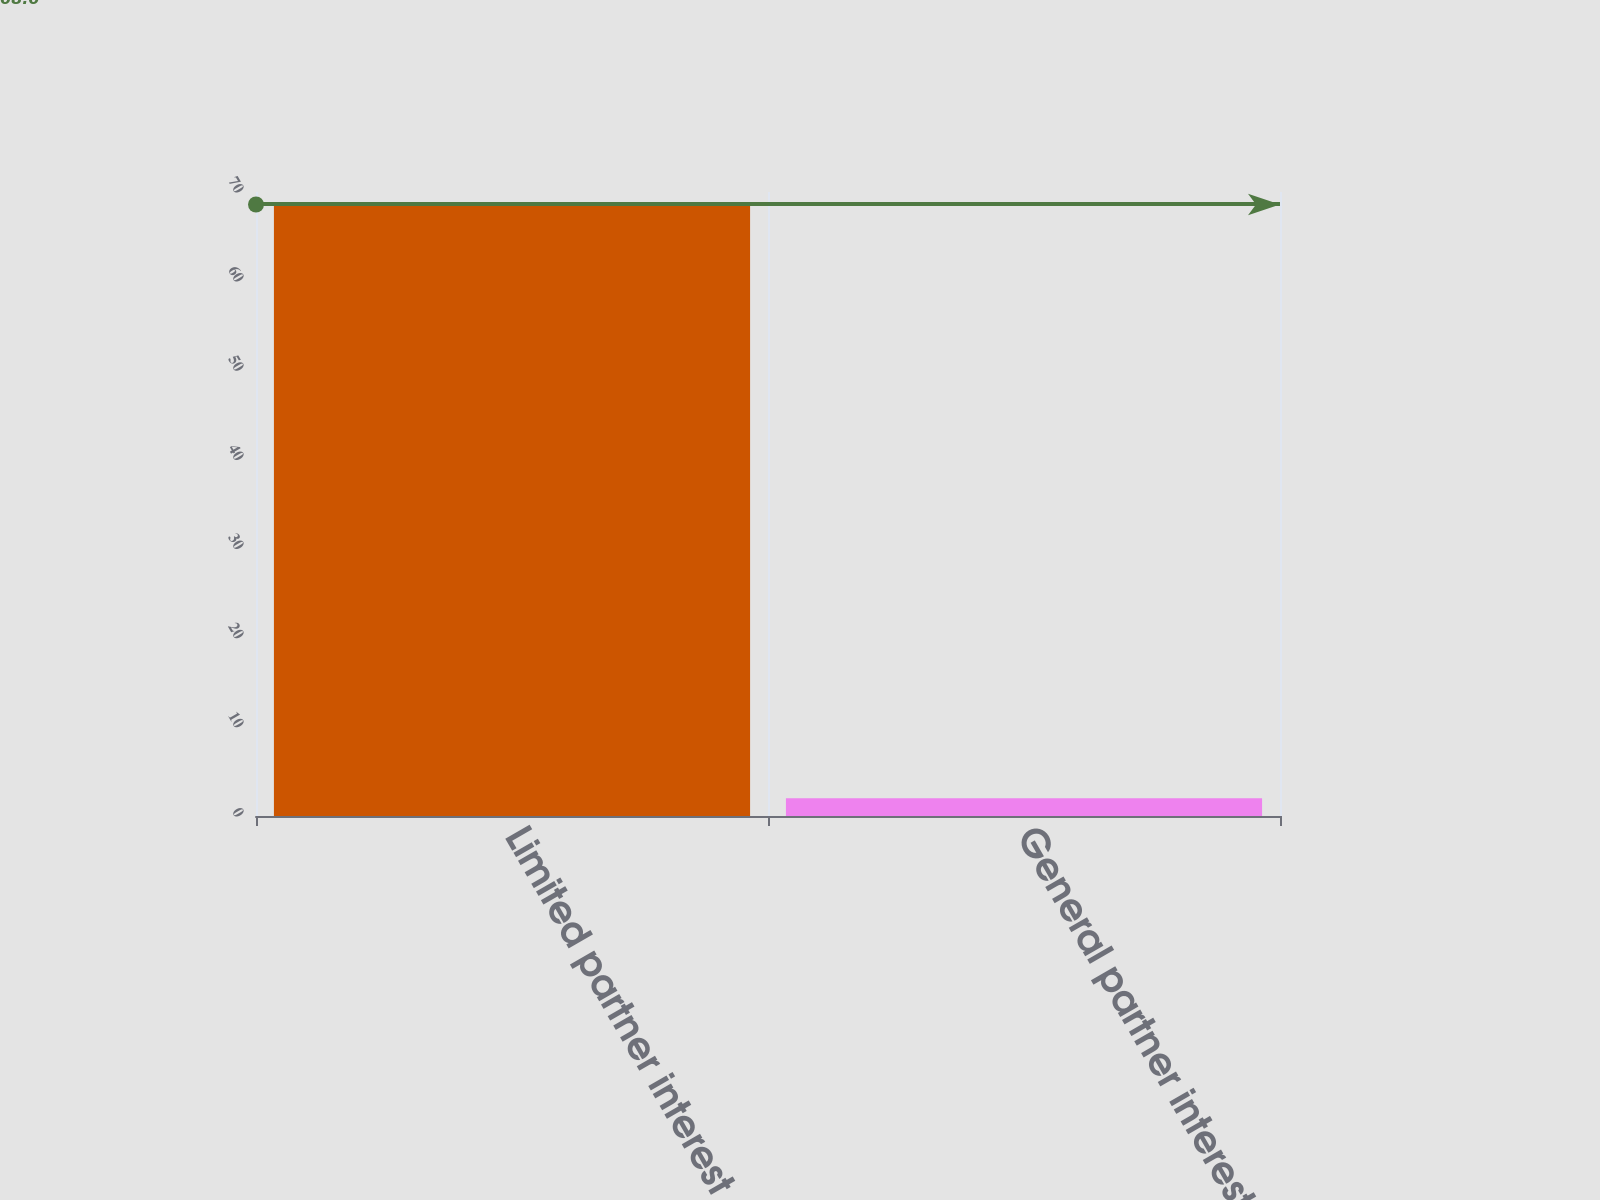Convert chart. <chart><loc_0><loc_0><loc_500><loc_500><bar_chart><fcel>Limited partner interest<fcel>General partner interest<nl><fcel>68.6<fcel>2<nl></chart> 